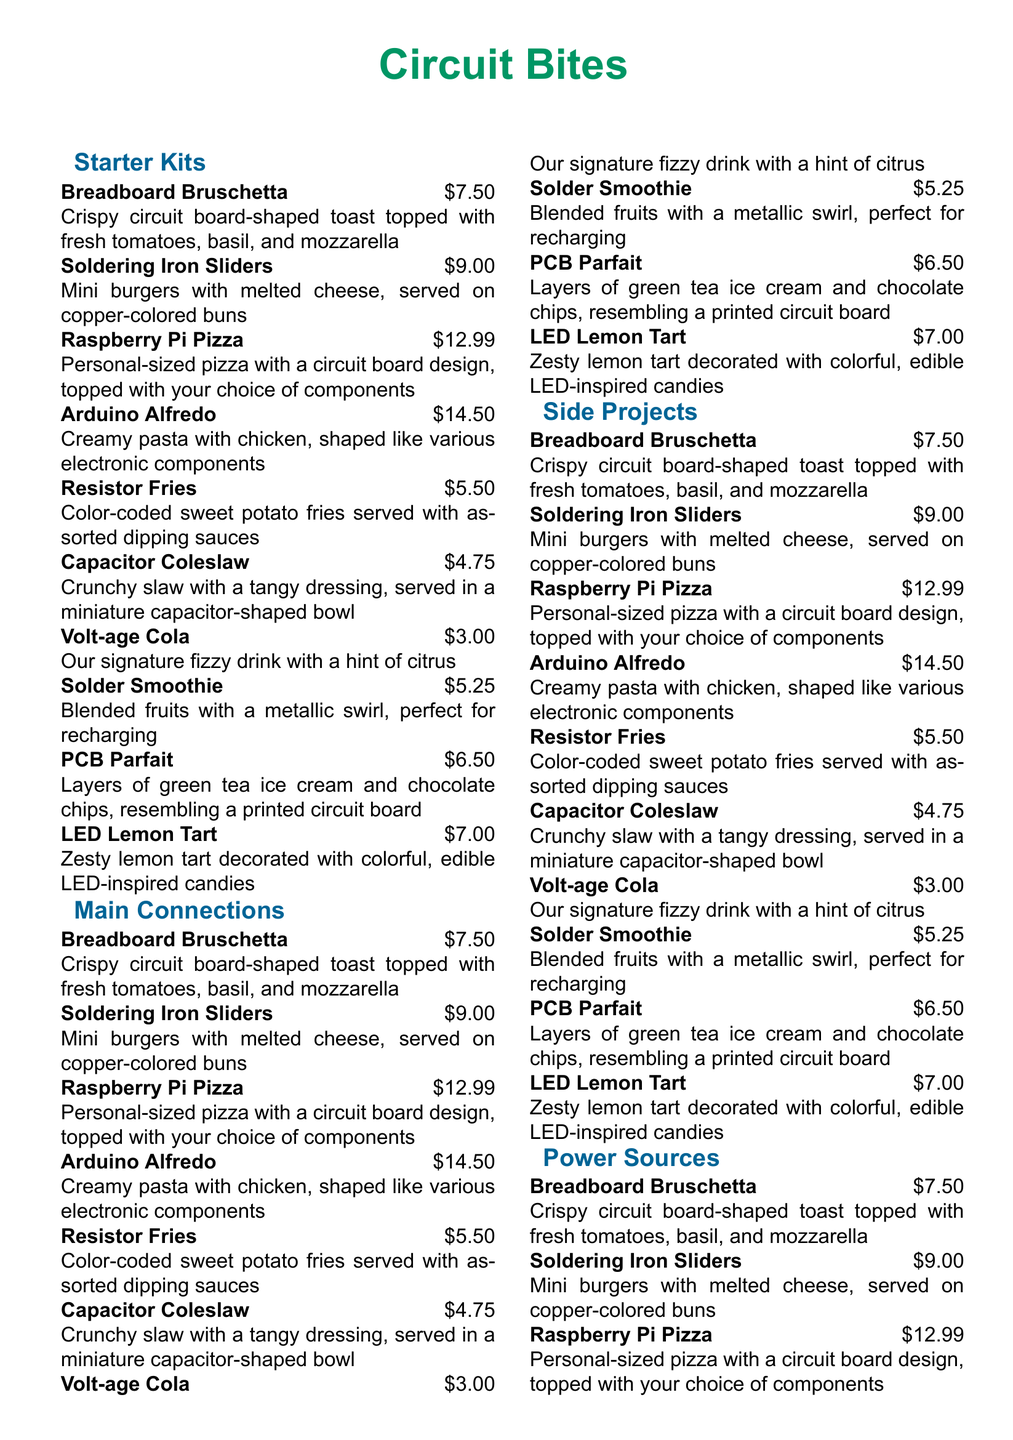What are the names of the sections in the menu? The sections listed in the menu are "Starter Kits", "Main Connections", "Side Projects", "Power Sources", and "Debugger's Desserts".
Answer: Starter Kits, Main Connections, Side Projects, Power Sources, Debugger's Desserts How much does the Raspberry Pi Pizza cost? The price listed for the Raspberry Pi Pizza in the menu is $12.99.
Answer: $12.99 What is the main ingredient in the Soldering Iron Sliders? The Soldering Iron Sliders are described as mini burgers with melted cheese.
Answer: Mini burgers with melted cheese Which dish is served in a capacitor-shaped bowl? The dish served in a miniature capacitor-shaped bowl is the Capacitor Coleslaw.
Answer: Capacitor Coleslaw What is the total price of the two cheapest items? The two cheapest items are Capacitor Coleslaw at $4.75 and Resistor Fries at $5.50, totaling $10.25.
Answer: $10.25 What beverage is mentioned in the menu? The menu includes a fizzy drink named "Volt-age Cola".
Answer: Volt-age Cola Which dish includes fruit and is blended? The blended dish that includes fruit is called the Solder Smoothie.
Answer: Solder Smoothie What type of dessert has layers resembling a printed circuit board? The dessert that has layers resembling a printed circuit board is the PCB Parfait.
Answer: PCB Parfait What is the theme of the menu? The theme of the menu is DIY-inspired dishes for long tinkering sessions.
Answer: DIY-inspired dishes 